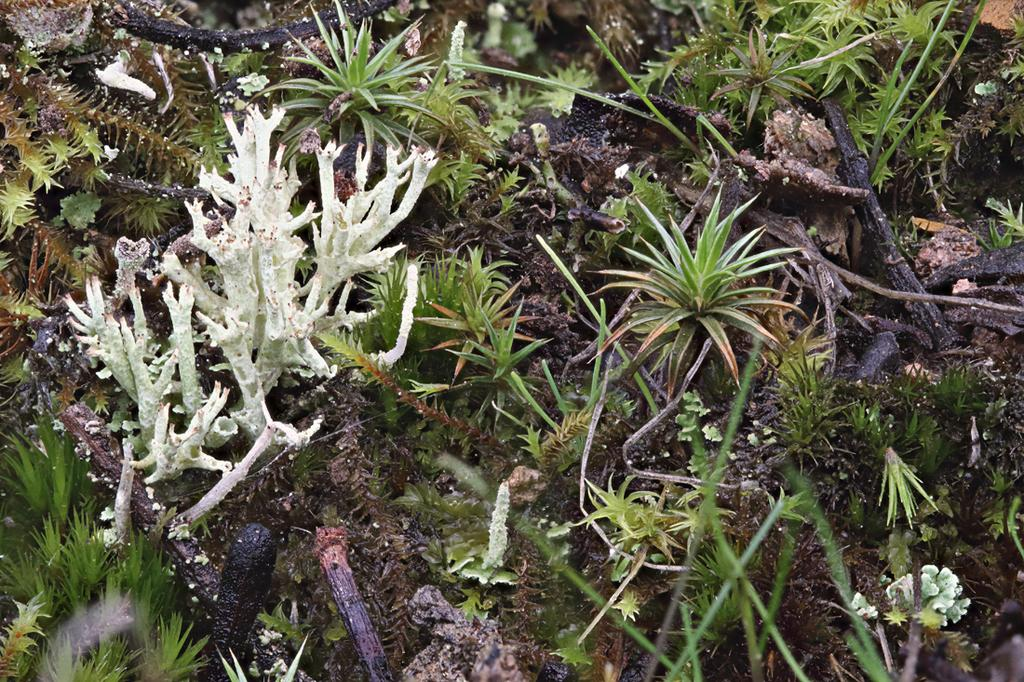What type of living organisms can be seen in the image? Plants can be seen in the image. Where are the plants located in the image? The plants are present all over the image. What type of zipper can be seen on the plants in the image? There is no zipper present on the plants in the image. What territory do the plants in the image belong to? The image does not provide information about the territory or location of the plants. 